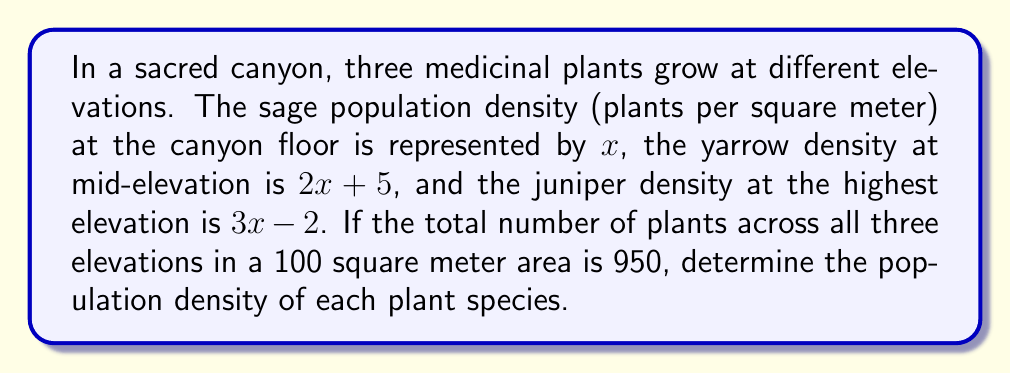Give your solution to this math problem. Let's approach this step-by-step:

1) First, we need to set up an equation based on the given information:
   
   $100x + 100(2x + 5) + 100(3x - 2) = 950$

   This equation represents the total number of plants in a 100 square meter area at each elevation.

2) Simplify the equation:
   
   $100x + 200x + 500 + 300x - 200 = 950$
   $600x + 300 = 950$

3) Solve for $x$:
   
   $600x = 650$
   $x = \frac{650}{600} = \frac{13}{12} \approx 1.083$

4) Now that we know $x$, we can calculate the density for each plant:

   Sage (canyon floor): $x = \frac{13}{12}$ plants per square meter

   Yarrow (mid-elevation): $2x + 5 = 2(\frac{13}{12}) + 5 = \frac{13}{6} + 5 = \frac{13}{6} + \frac{30}{6} = \frac{43}{6} \approx 7.167$ plants per square meter

   Juniper (highest elevation): $3x - 2 = 3(\frac{13}{12}) - 2 = \frac{13}{4} - 2 = \frac{13}{4} - \frac{8}{4} = \frac{5}{4} = 1.25$ plants per square meter
Answer: Sage: $\frac{13}{12}$ plants/m²
Yarrow: $\frac{43}{6}$ plants/m²
Juniper: $\frac{5}{4}$ plants/m² 